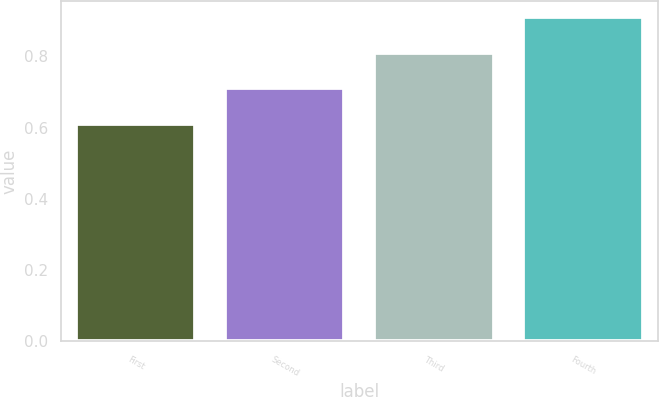<chart> <loc_0><loc_0><loc_500><loc_500><bar_chart><fcel>First<fcel>Second<fcel>Third<fcel>Fourth<nl><fcel>0.61<fcel>0.71<fcel>0.81<fcel>0.91<nl></chart> 